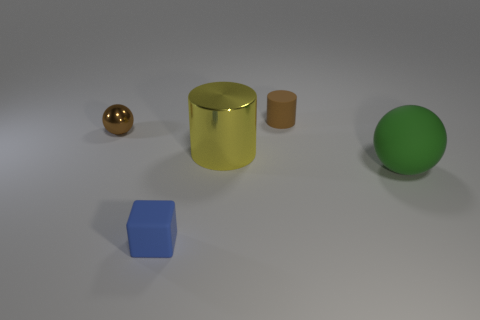Is the tiny shiny sphere the same color as the tiny cylinder?
Offer a very short reply. Yes. Is the number of small brown spheres greater than the number of small gray rubber cylinders?
Offer a terse response. Yes. Are there any other things that have the same color as the tiny shiny object?
Your response must be concise. Yes. Is the tiny brown sphere made of the same material as the big cylinder?
Provide a succinct answer. Yes. Is the number of small blue things less than the number of big red cylinders?
Give a very brief answer. No. Is the big green matte thing the same shape as the brown metal object?
Your answer should be compact. Yes. The large cylinder has what color?
Offer a terse response. Yellow. What number of other objects are the same material as the tiny block?
Provide a succinct answer. 2. What number of green things are either rubber balls or small metal objects?
Make the answer very short. 1. Does the tiny thing that is behind the small metallic ball have the same shape as the large yellow object that is behind the green rubber ball?
Provide a short and direct response. Yes. 